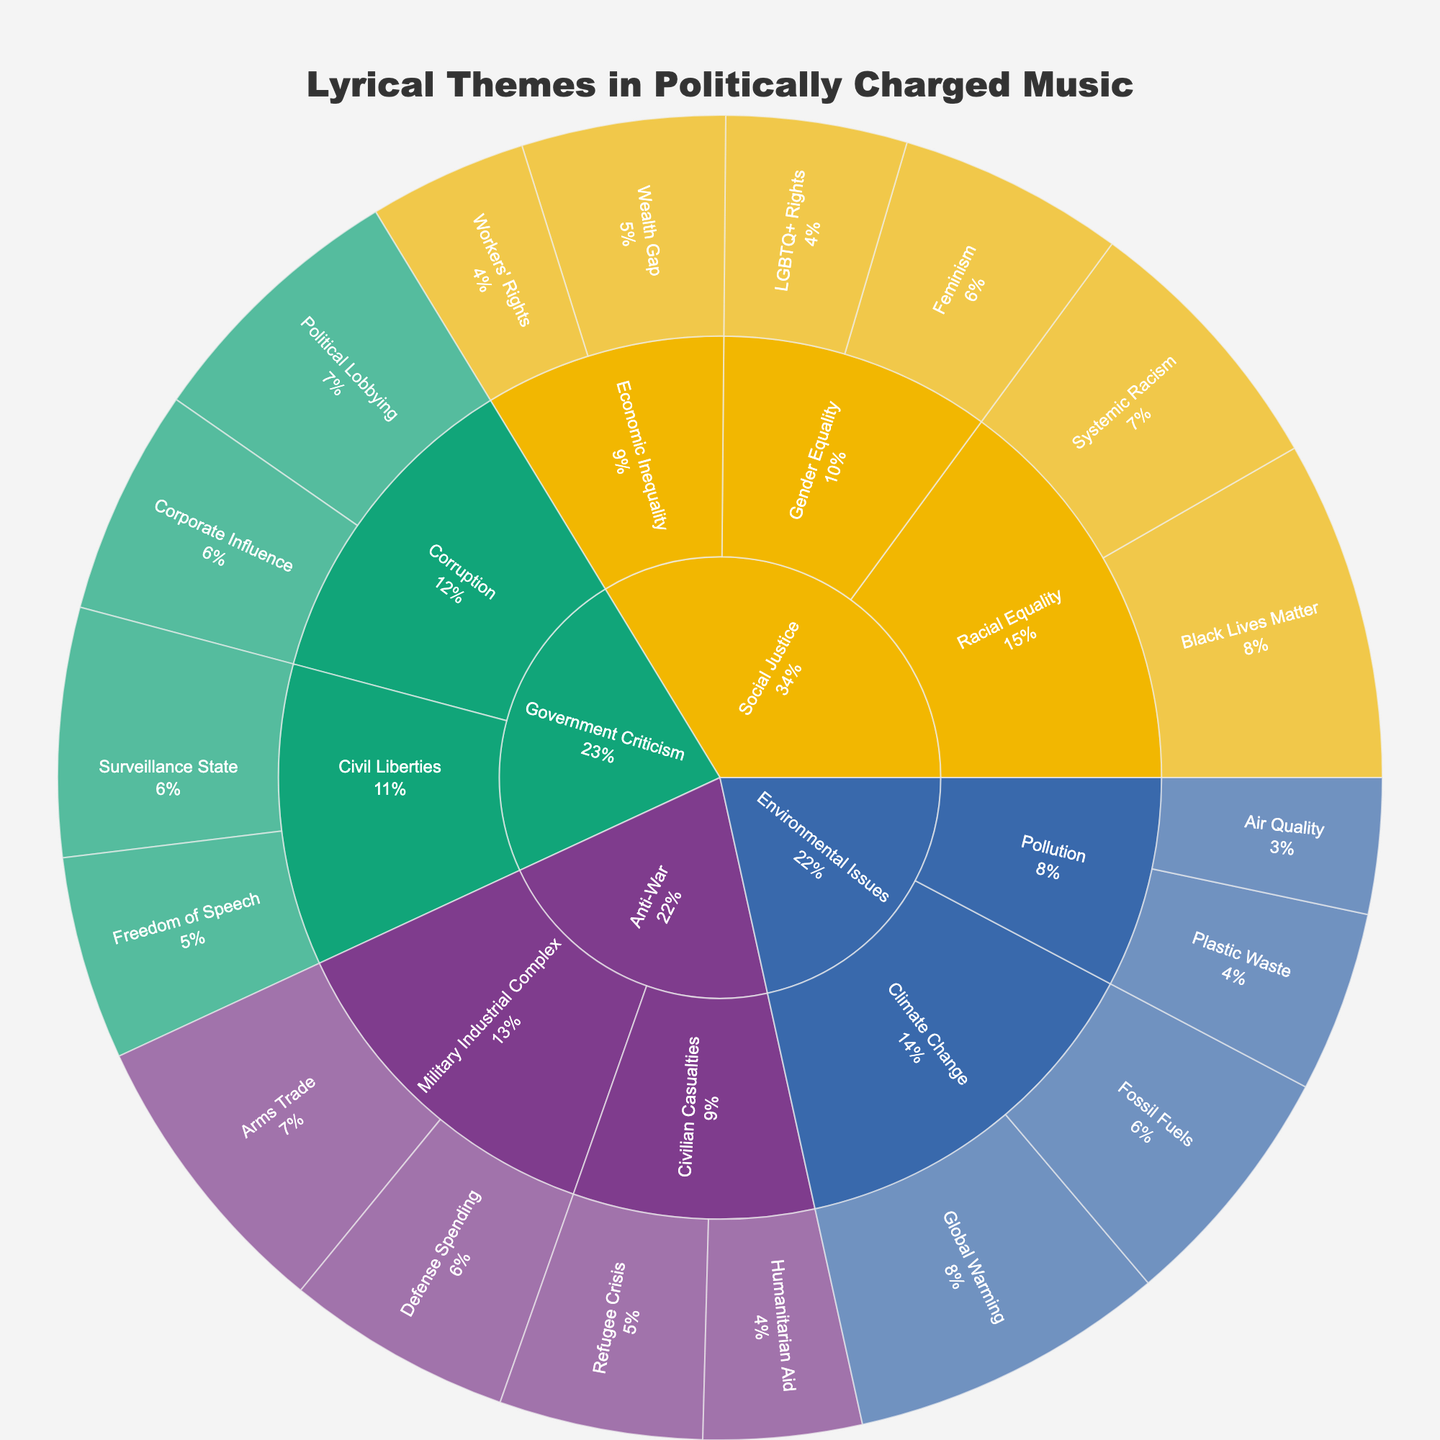What's the highest-valued topic within the category of Social Justice? The sunburst plot shows that the topic Black Lives Matter under the subcategory Racial Equality within Social Justice has a value of 15, which is the highest in that category.
Answer: Black Lives Matter Within the category of Environmental Issues, which subcategory has the highest aggregate value? Adding the values for Climate Change (14 + 11 = 25) and Pollution (8 + 6 = 14), Climate Change has a higher aggregate value of 25.
Answer: Climate Change Which category has the highest total value? Summing up all values for all categories, Social Justice (61), Environmental Issues (39), Anti-War (39), Government Criticism (42), Social Justice has the highest total value.
Answer: Social Justice What proportion of the total value for the Government Criticism category is made up by the topic Political Lobbying? The total value for Government Criticism is 42. The value of Political Lobbying is 12. The proportion is 12/42 = 0.2857, which is approximately 28.57%.
Answer: 28.57% Which subcategory under the Anti-War category has higher values, Civilian Casualties or Military Industrial Complex? The Military Industrial Complex subcategory has values of Arms Trade (13) and Defense Spending (10), totaling 23. Civilian Casualties has values of Refugee Crisis (9) and Humanitarian Aid (7), totaling 16. Thus, Military Industrial Complex has higher values.
Answer: Military Industrial Complex Compare the topic value for Global Warming under Climate Change with the value for Systemic Racism under Racial Equality. Which one is larger and by how much? The value of Global Warming is 14, and the value of Systemic Racism is 12. 14 - 12 = 2, so Global Warming is larger by 2.
Answer: Global Warming by 2 What is the combined value of the topics under the subcategory Gender Equality in the Social Justice category? The two topics under Gender Equality are Feminism (10) and LGBTQ+ Rights (8). Adding 10 + 8 = 18 gives the combined value.
Answer: 18 Which subcategory within Government Criticism has the higher total value, Corruption or Civil Liberties? Summing the values under Corruption (Political Lobbying 12 + Corporate Influence 10 = 22) and Civil Liberties (Surveillance State 11 + Freedom of Speech 9 = 20), Corruption has a higher total value of 22.
Answer: Corruption How does the value of Wealth Gap compare to the value of Plastic Waste? Wealth Gap has a value of 9, and Plastic Waste has a value of 8. Therefore, Wealth Gap is larger by 1.
Answer: 1 Is the total value of topics under Climate Change higher than the total value of topics under Racial Equality? The total value of topics under Climate Change is 14 + 11 = 25. The total value of topics under Racial Equality is 15 + 12 = 27. Racial Equality has a higher total value.
Answer: No 